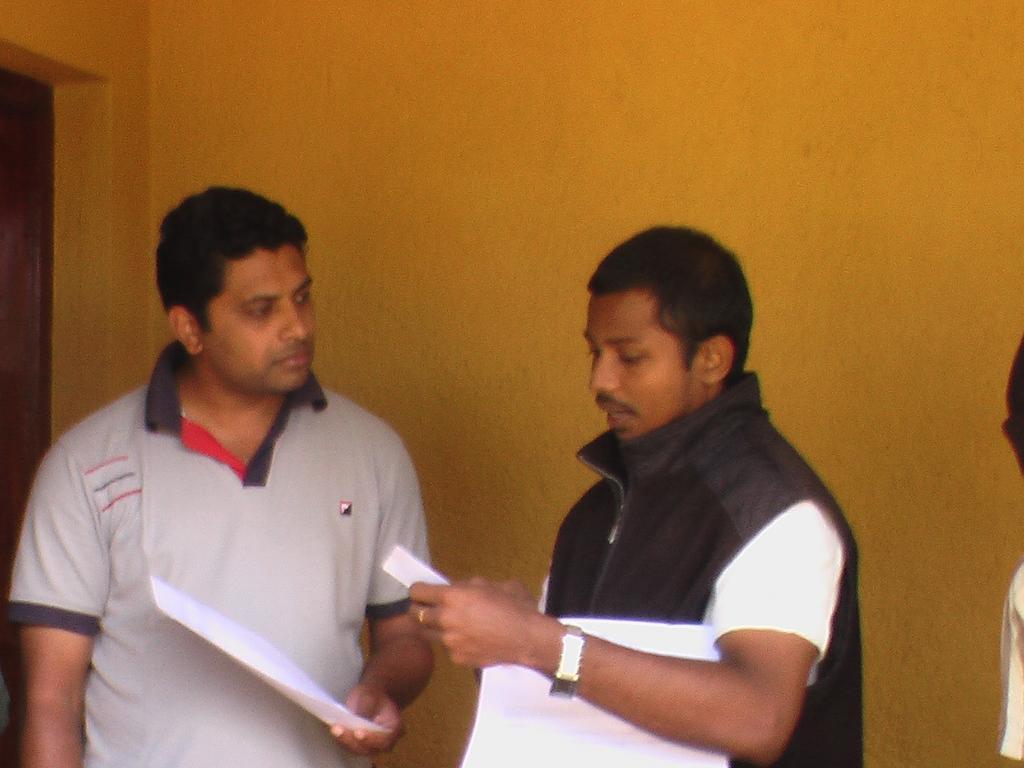Please provide a concise description of this image. In this picture I can see there are two people and one of them is speaking. They are holding papers and there is a wall in the backdrop. 